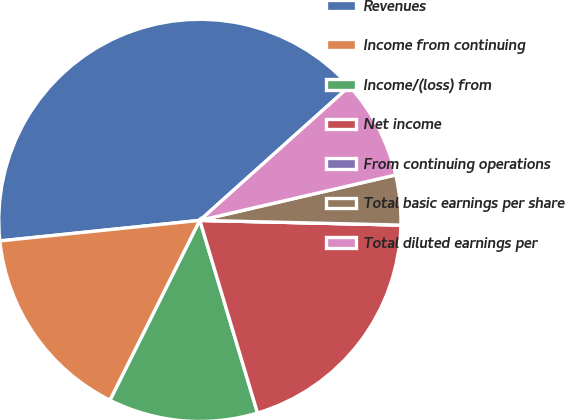Convert chart. <chart><loc_0><loc_0><loc_500><loc_500><pie_chart><fcel>Revenues<fcel>Income from continuing<fcel>Income/(loss) from<fcel>Net income<fcel>From continuing operations<fcel>Total basic earnings per share<fcel>Total diluted earnings per<nl><fcel>40.0%<fcel>16.0%<fcel>12.0%<fcel>20.0%<fcel>0.0%<fcel>4.0%<fcel>8.0%<nl></chart> 